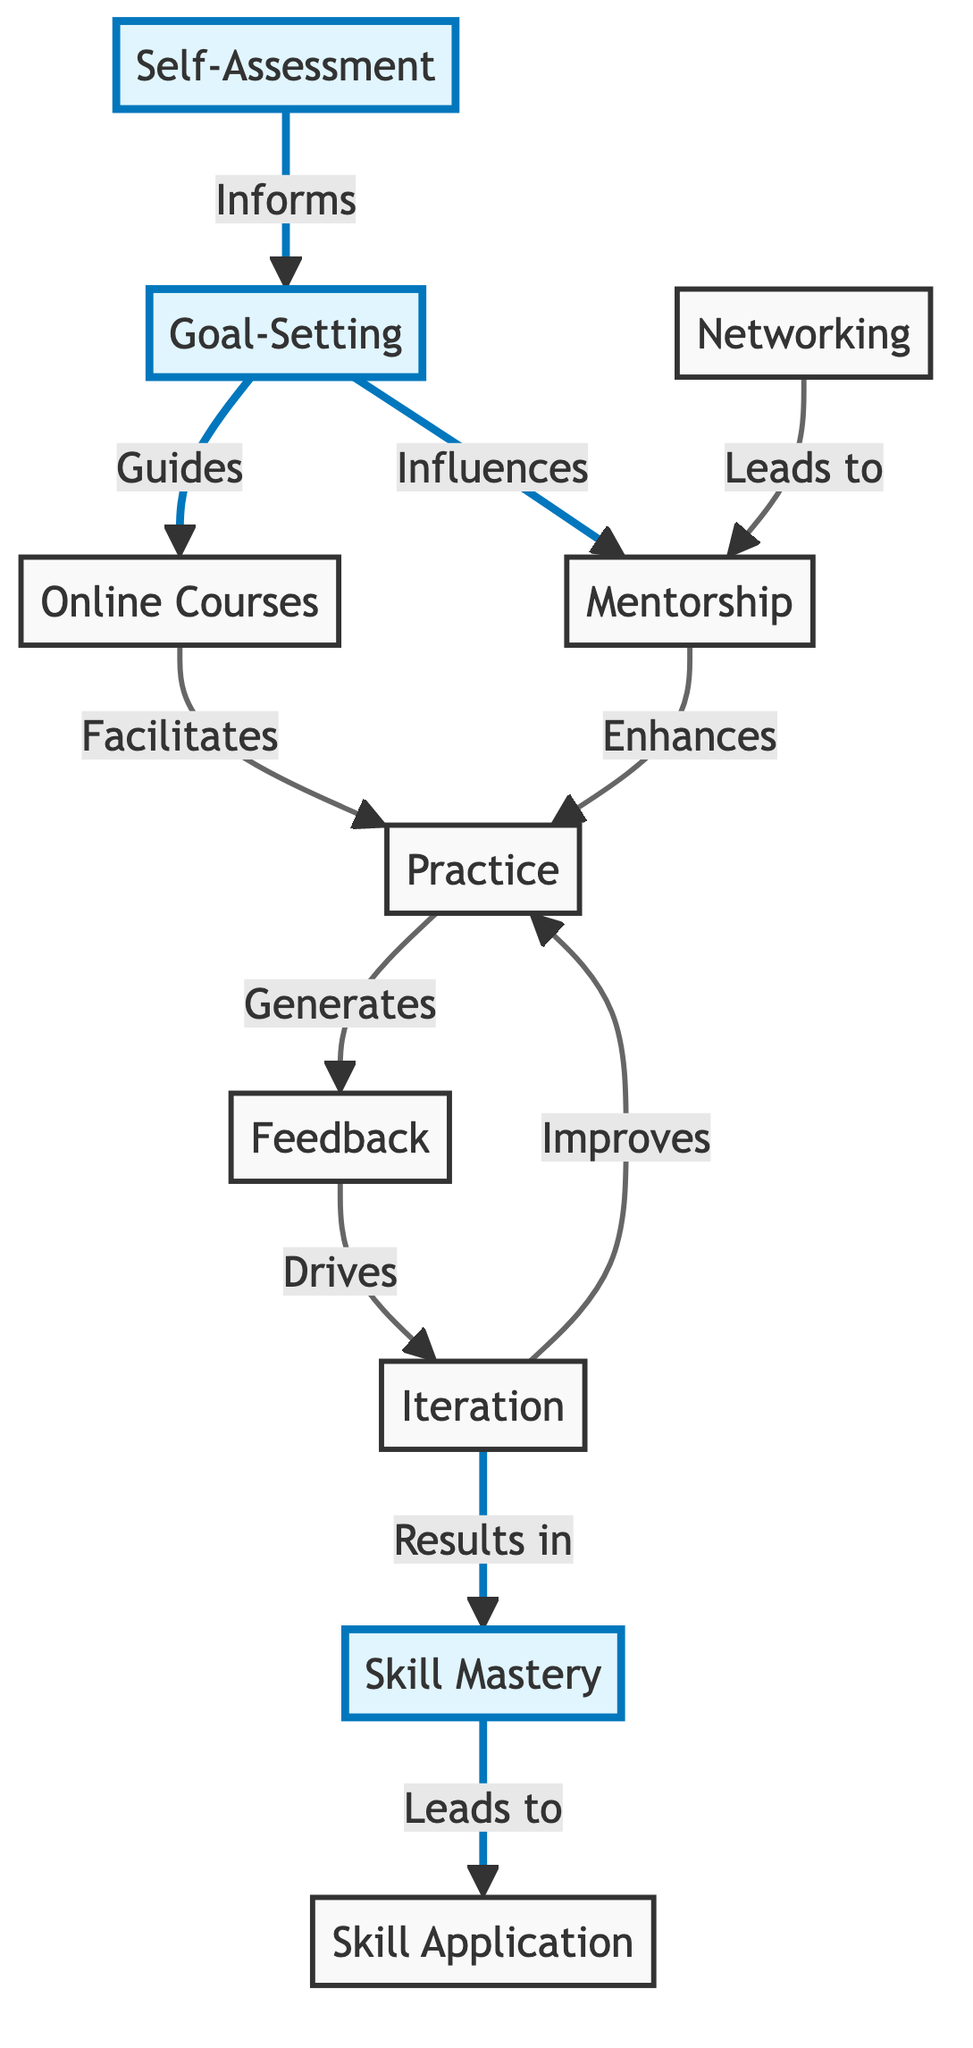What is the first step in the skill acquisition pathway? The diagram indicates that the first step is Self-Assessment, as it is the initial node in the flowchart, leading to Goal-Setting.
Answer: Self-Assessment How many nodes are in the diagram? By counting each unique node represented in the diagram, there are a total of 10 distinct nodes involved in the skill acquisition pathways.
Answer: 10 Which node directly influences Online Courses? From the flow of the diagram, Goal-Setting is shown to guide Online Courses directly, as indicated by the arrow connecting them.
Answer: Goal-Setting What role does Feedback play in the skill acquisition pathway? Feedback serves as a crucial element in the diagram, as it is generated from Practice, drives Iteration, and ultimately results in Skill Mastery, indicating its importance in enhancing skills.
Answer: Drives Iteration How does Networking affect the skill acquisition process? Networking leads to Mentorship, which plays a role in enhancing Practice. This depicts that Networking indirectly impacts skill development through collaborative relationships.
Answer: Leads to Mentorship Which node results in Skill Mastery? The diagram shows that Iteration results in Skill Mastery, emphasizing the importance of continuous improvement in achieving a high level of skill.
Answer: Iteration What is the connection between Practice and Feedback? The diagram shows that Practice generates Feedback, creating a circular relationship where practice enhances skills, and feedback helps to refine those skills further.
Answer: Generates Which two nodes are highlighted in the diagram? The highlighted nodes in the diagram are Self-Assessment, Goal-Setting, and Skill Mastery, indicating their significant roles in the skill acquisition process.
Answer: Self-Assessment, Goal-Setting, Skill Mastery What comes after Skill Mastery? According to the diagram, Skill Application follows Skill Mastery, suggesting that mastering a skill leads to the ability to apply it practically.
Answer: Skill Application 